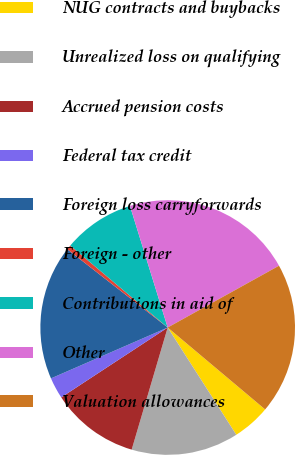Convert chart. <chart><loc_0><loc_0><loc_500><loc_500><pie_chart><fcel>NUG contracts and buybacks<fcel>Unrealized loss on qualifying<fcel>Accrued pension costs<fcel>Federal tax credit<fcel>Foreign loss carryforwards<fcel>Foreign - other<fcel>Contributions in aid of<fcel>Other<fcel>Valuation allowances<nl><fcel>4.82%<fcel>13.62%<fcel>11.19%<fcel>2.7%<fcel>17.08%<fcel>0.59%<fcel>9.08%<fcel>21.72%<fcel>19.19%<nl></chart> 